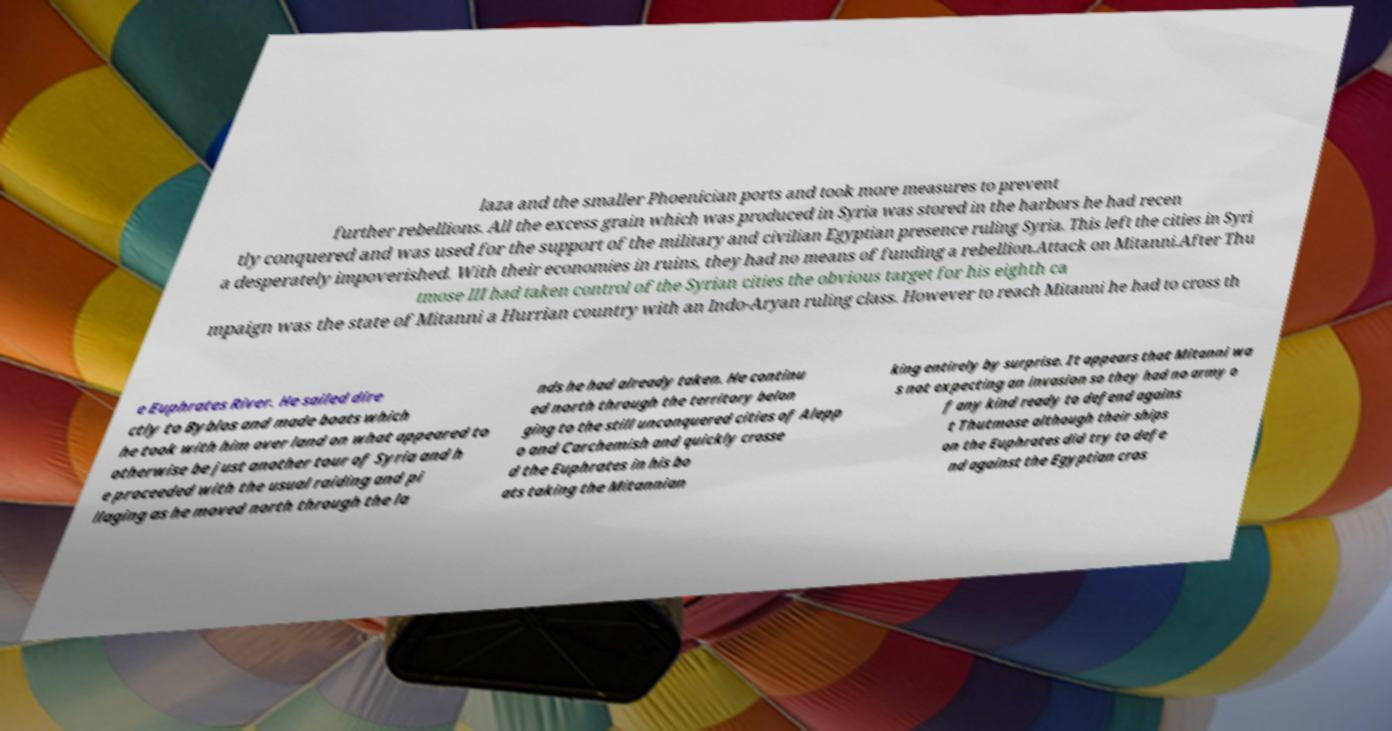Please identify and transcribe the text found in this image. laza and the smaller Phoenician ports and took more measures to prevent further rebellions. All the excess grain which was produced in Syria was stored in the harbors he had recen tly conquered and was used for the support of the military and civilian Egyptian presence ruling Syria. This left the cities in Syri a desperately impoverished. With their economies in ruins, they had no means of funding a rebellion.Attack on Mitanni.After Thu tmose III had taken control of the Syrian cities the obvious target for his eighth ca mpaign was the state of Mitanni a Hurrian country with an Indo-Aryan ruling class. However to reach Mitanni he had to cross th e Euphrates River. He sailed dire ctly to Byblos and made boats which he took with him over land on what appeared to otherwise be just another tour of Syria and h e proceeded with the usual raiding and pi llaging as he moved north through the la nds he had already taken. He continu ed north through the territory belon ging to the still unconquered cities of Alepp o and Carchemish and quickly crosse d the Euphrates in his bo ats taking the Mitannian king entirely by surprise. It appears that Mitanni wa s not expecting an invasion so they had no army o f any kind ready to defend agains t Thutmose although their ships on the Euphrates did try to defe nd against the Egyptian cros 